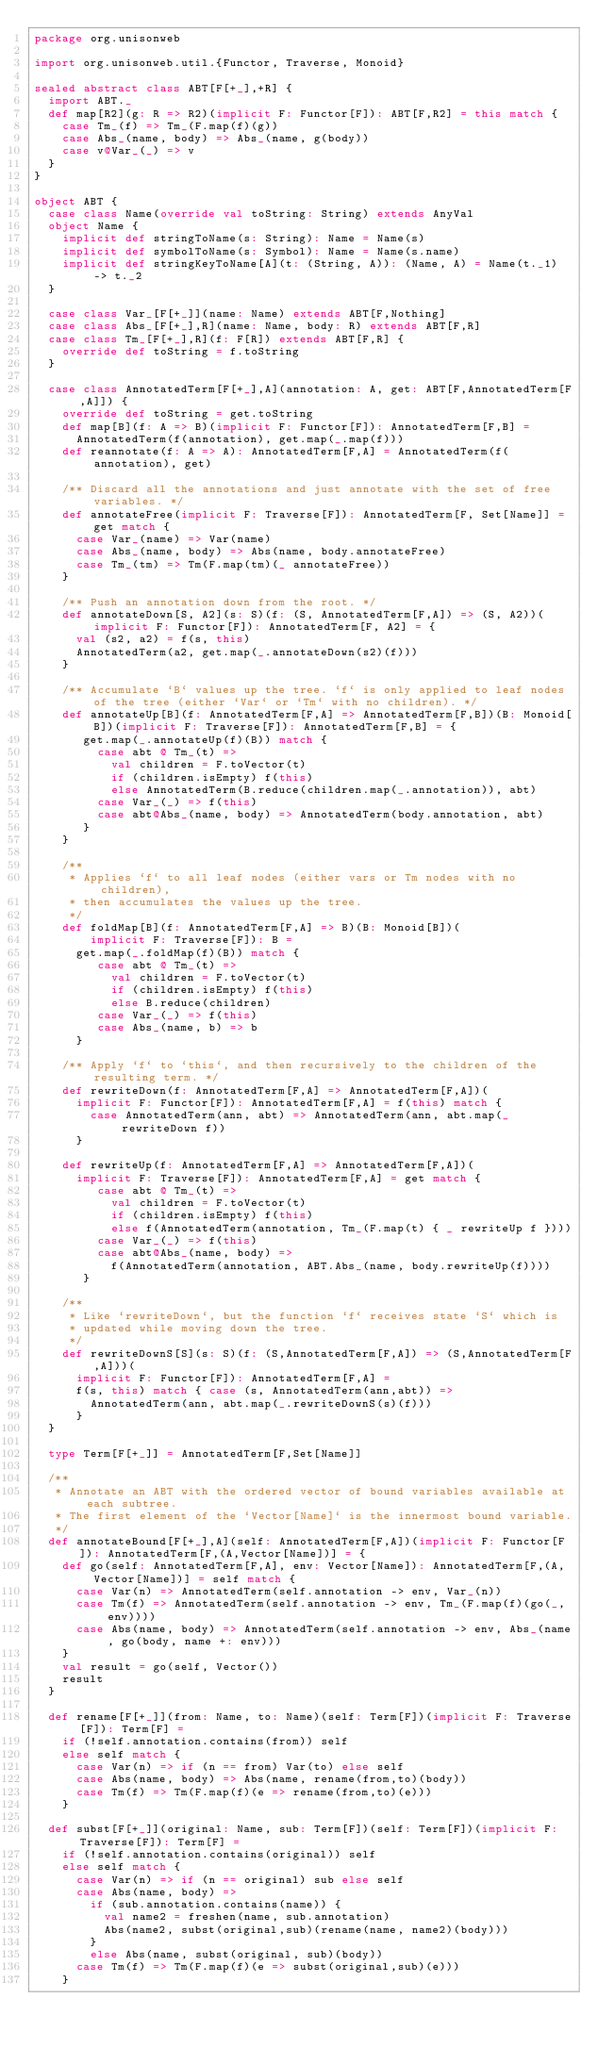Convert code to text. <code><loc_0><loc_0><loc_500><loc_500><_Scala_>package org.unisonweb

import org.unisonweb.util.{Functor, Traverse, Monoid}

sealed abstract class ABT[F[+_],+R] {
  import ABT._
  def map[R2](g: R => R2)(implicit F: Functor[F]): ABT[F,R2] = this match {
    case Tm_(f) => Tm_(F.map(f)(g))
    case Abs_(name, body) => Abs_(name, g(body))
    case v@Var_(_) => v
  }
}

object ABT {
  case class Name(override val toString: String) extends AnyVal
  object Name {
    implicit def stringToName(s: String): Name = Name(s)
    implicit def symbolToName(s: Symbol): Name = Name(s.name)
    implicit def stringKeyToName[A](t: (String, A)): (Name, A) = Name(t._1) -> t._2
  }

  case class Var_[F[+_]](name: Name) extends ABT[F,Nothing]
  case class Abs_[F[+_],R](name: Name, body: R) extends ABT[F,R]
  case class Tm_[F[+_],R](f: F[R]) extends ABT[F,R] {
    override def toString = f.toString
  }

  case class AnnotatedTerm[F[+_],A](annotation: A, get: ABT[F,AnnotatedTerm[F,A]]) {
    override def toString = get.toString
    def map[B](f: A => B)(implicit F: Functor[F]): AnnotatedTerm[F,B] =
      AnnotatedTerm(f(annotation), get.map(_.map(f)))
    def reannotate(f: A => A): AnnotatedTerm[F,A] = AnnotatedTerm(f(annotation), get)

    /** Discard all the annotations and just annotate with the set of free variables. */
    def annotateFree(implicit F: Traverse[F]): AnnotatedTerm[F, Set[Name]] = get match {
      case Var_(name) => Var(name)
      case Abs_(name, body) => Abs(name, body.annotateFree)
      case Tm_(tm) => Tm(F.map(tm)(_ annotateFree))
    }

    /** Push an annotation down from the root. */
    def annotateDown[S, A2](s: S)(f: (S, AnnotatedTerm[F,A]) => (S, A2))(implicit F: Functor[F]): AnnotatedTerm[F, A2] = {
      val (s2, a2) = f(s, this)
      AnnotatedTerm(a2, get.map(_.annotateDown(s2)(f)))
    }

    /** Accumulate `B` values up the tree. `f` is only applied to leaf nodes of the tree (either `Var` or `Tm` with no children). */
    def annotateUp[B](f: AnnotatedTerm[F,A] => AnnotatedTerm[F,B])(B: Monoid[B])(implicit F: Traverse[F]): AnnotatedTerm[F,B] = {
       get.map(_.annotateUp(f)(B)) match {
         case abt @ Tm_(t) =>
           val children = F.toVector(t)
           if (children.isEmpty) f(this)
           else AnnotatedTerm(B.reduce(children.map(_.annotation)), abt)
         case Var_(_) => f(this)
         case abt@Abs_(name, body) => AnnotatedTerm(body.annotation, abt)
       }
    }

    /**
     * Applies `f` to all leaf nodes (either vars or Tm nodes with no children),
     * then accumulates the values up the tree.
     */
    def foldMap[B](f: AnnotatedTerm[F,A] => B)(B: Monoid[B])(
        implicit F: Traverse[F]): B =
      get.map(_.foldMap(f)(B)) match {
         case abt @ Tm_(t) =>
           val children = F.toVector(t)
           if (children.isEmpty) f(this)
           else B.reduce(children)
         case Var_(_) => f(this)
         case Abs_(name, b) => b
      }

    /** Apply `f` to `this`, and then recursively to the children of the resulting term. */
    def rewriteDown(f: AnnotatedTerm[F,A] => AnnotatedTerm[F,A])(
      implicit F: Functor[F]): AnnotatedTerm[F,A] = f(this) match {
        case AnnotatedTerm(ann, abt) => AnnotatedTerm(ann, abt.map(_ rewriteDown f))
      }

    def rewriteUp(f: AnnotatedTerm[F,A] => AnnotatedTerm[F,A])(
      implicit F: Traverse[F]): AnnotatedTerm[F,A] = get match {
         case abt @ Tm_(t) =>
           val children = F.toVector(t)
           if (children.isEmpty) f(this)
           else f(AnnotatedTerm(annotation, Tm_(F.map(t) { _ rewriteUp f })))
         case Var_(_) => f(this)
         case abt@Abs_(name, body) =>
           f(AnnotatedTerm(annotation, ABT.Abs_(name, body.rewriteUp(f))))
       }

    /**
     * Like `rewriteDown`, but the function `f` receives state `S` which is
     * updated while moving down the tree.
     */
    def rewriteDownS[S](s: S)(f: (S,AnnotatedTerm[F,A]) => (S,AnnotatedTerm[F,A]))(
      implicit F: Functor[F]): AnnotatedTerm[F,A] =
      f(s, this) match { case (s, AnnotatedTerm(ann,abt)) =>
        AnnotatedTerm(ann, abt.map(_.rewriteDownS(s)(f)))
      }
  }

  type Term[F[+_]] = AnnotatedTerm[F,Set[Name]]

  /**
   * Annotate an ABT with the ordered vector of bound variables available at each subtree.
   * The first element of the `Vector[Name]` is the innermost bound variable.
   */
  def annotateBound[F[+_],A](self: AnnotatedTerm[F,A])(implicit F: Functor[F]): AnnotatedTerm[F,(A,Vector[Name])] = {
    def go(self: AnnotatedTerm[F,A], env: Vector[Name]): AnnotatedTerm[F,(A,Vector[Name])] = self match {
      case Var(n) => AnnotatedTerm(self.annotation -> env, Var_(n))
      case Tm(f) => AnnotatedTerm(self.annotation -> env, Tm_(F.map(f)(go(_,env))))
      case Abs(name, body) => AnnotatedTerm(self.annotation -> env, Abs_(name, go(body, name +: env)))
    }
    val result = go(self, Vector())
    result
  }

  def rename[F[+_]](from: Name, to: Name)(self: Term[F])(implicit F: Traverse[F]): Term[F] =
    if (!self.annotation.contains(from)) self
    else self match {
      case Var(n) => if (n == from) Var(to) else self
      case Abs(name, body) => Abs(name, rename(from,to)(body))
      case Tm(f) => Tm(F.map(f)(e => rename(from,to)(e)))
    }

  def subst[F[+_]](original: Name, sub: Term[F])(self: Term[F])(implicit F: Traverse[F]): Term[F] =
    if (!self.annotation.contains(original)) self
    else self match {
      case Var(n) => if (n == original) sub else self
      case Abs(name, body) =>
        if (sub.annotation.contains(name)) {
          val name2 = freshen(name, sub.annotation)
          Abs(name2, subst(original,sub)(rename(name, name2)(body)))
        }
        else Abs(name, subst(original, sub)(body))
      case Tm(f) => Tm(F.map(f)(e => subst(original,sub)(e)))
    }
</code> 